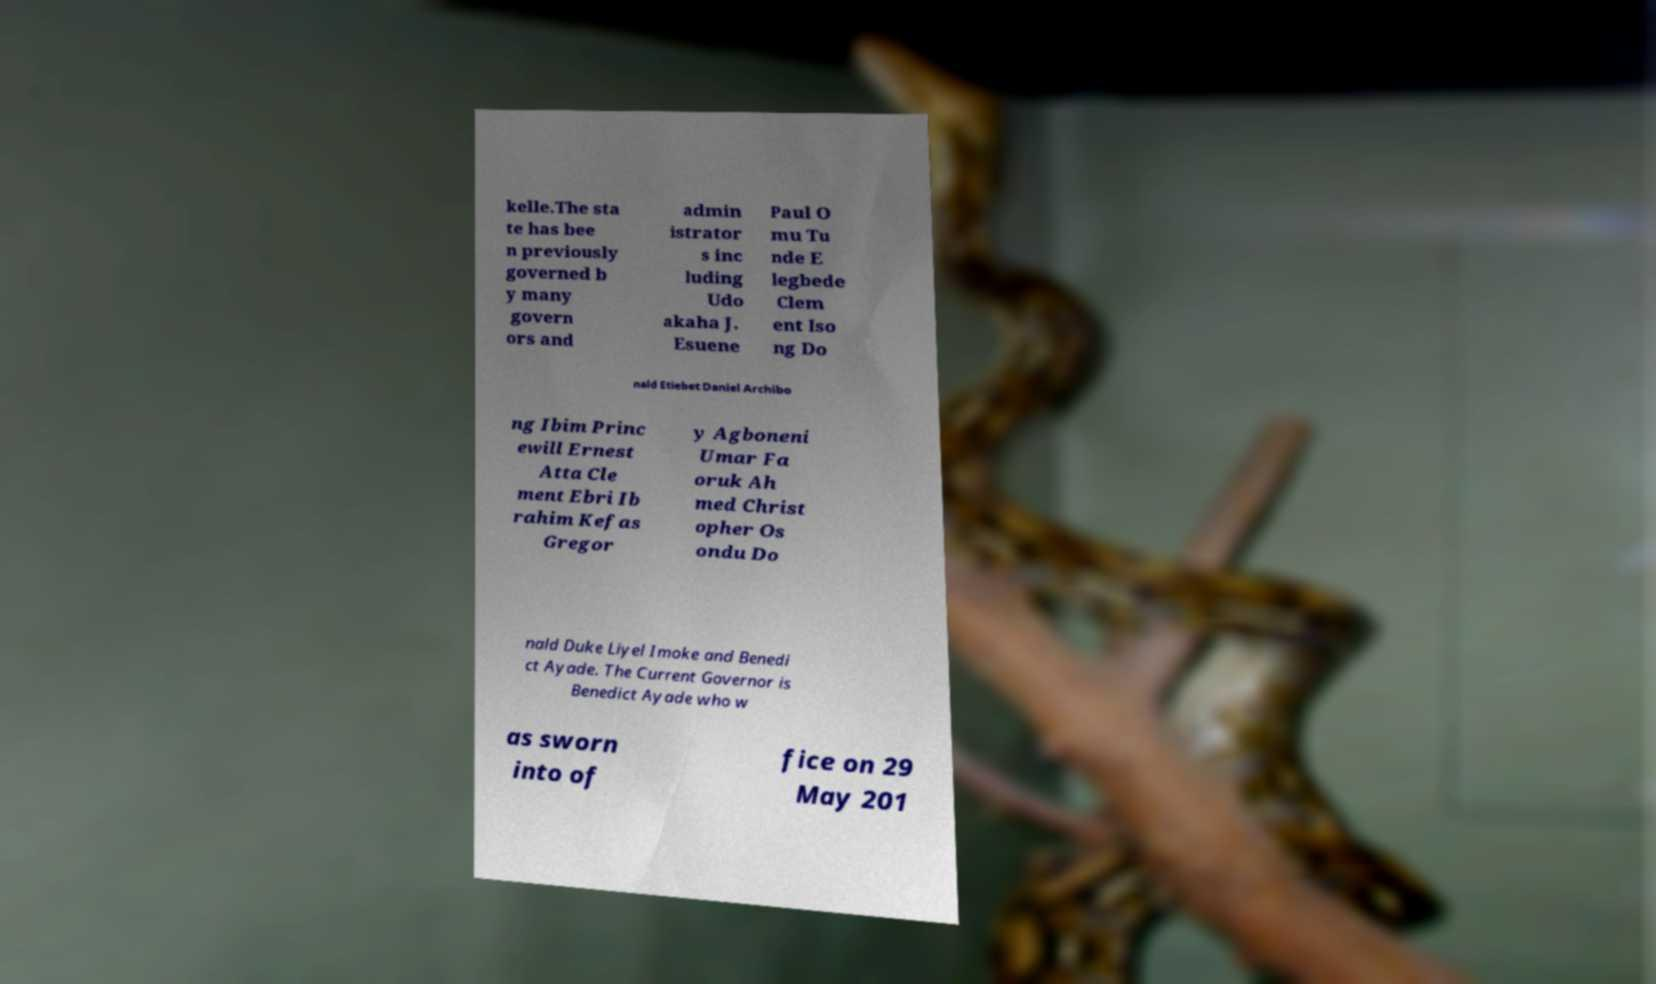Could you extract and type out the text from this image? kelle.The sta te has bee n previously governed b y many govern ors and admin istrator s inc luding Udo akaha J. Esuene Paul O mu Tu nde E legbede Clem ent Iso ng Do nald Etiebet Daniel Archibo ng Ibim Princ ewill Ernest Atta Cle ment Ebri Ib rahim Kefas Gregor y Agboneni Umar Fa oruk Ah med Christ opher Os ondu Do nald Duke Liyel Imoke and Benedi ct Ayade. The Current Governor is Benedict Ayade who w as sworn into of fice on 29 May 201 